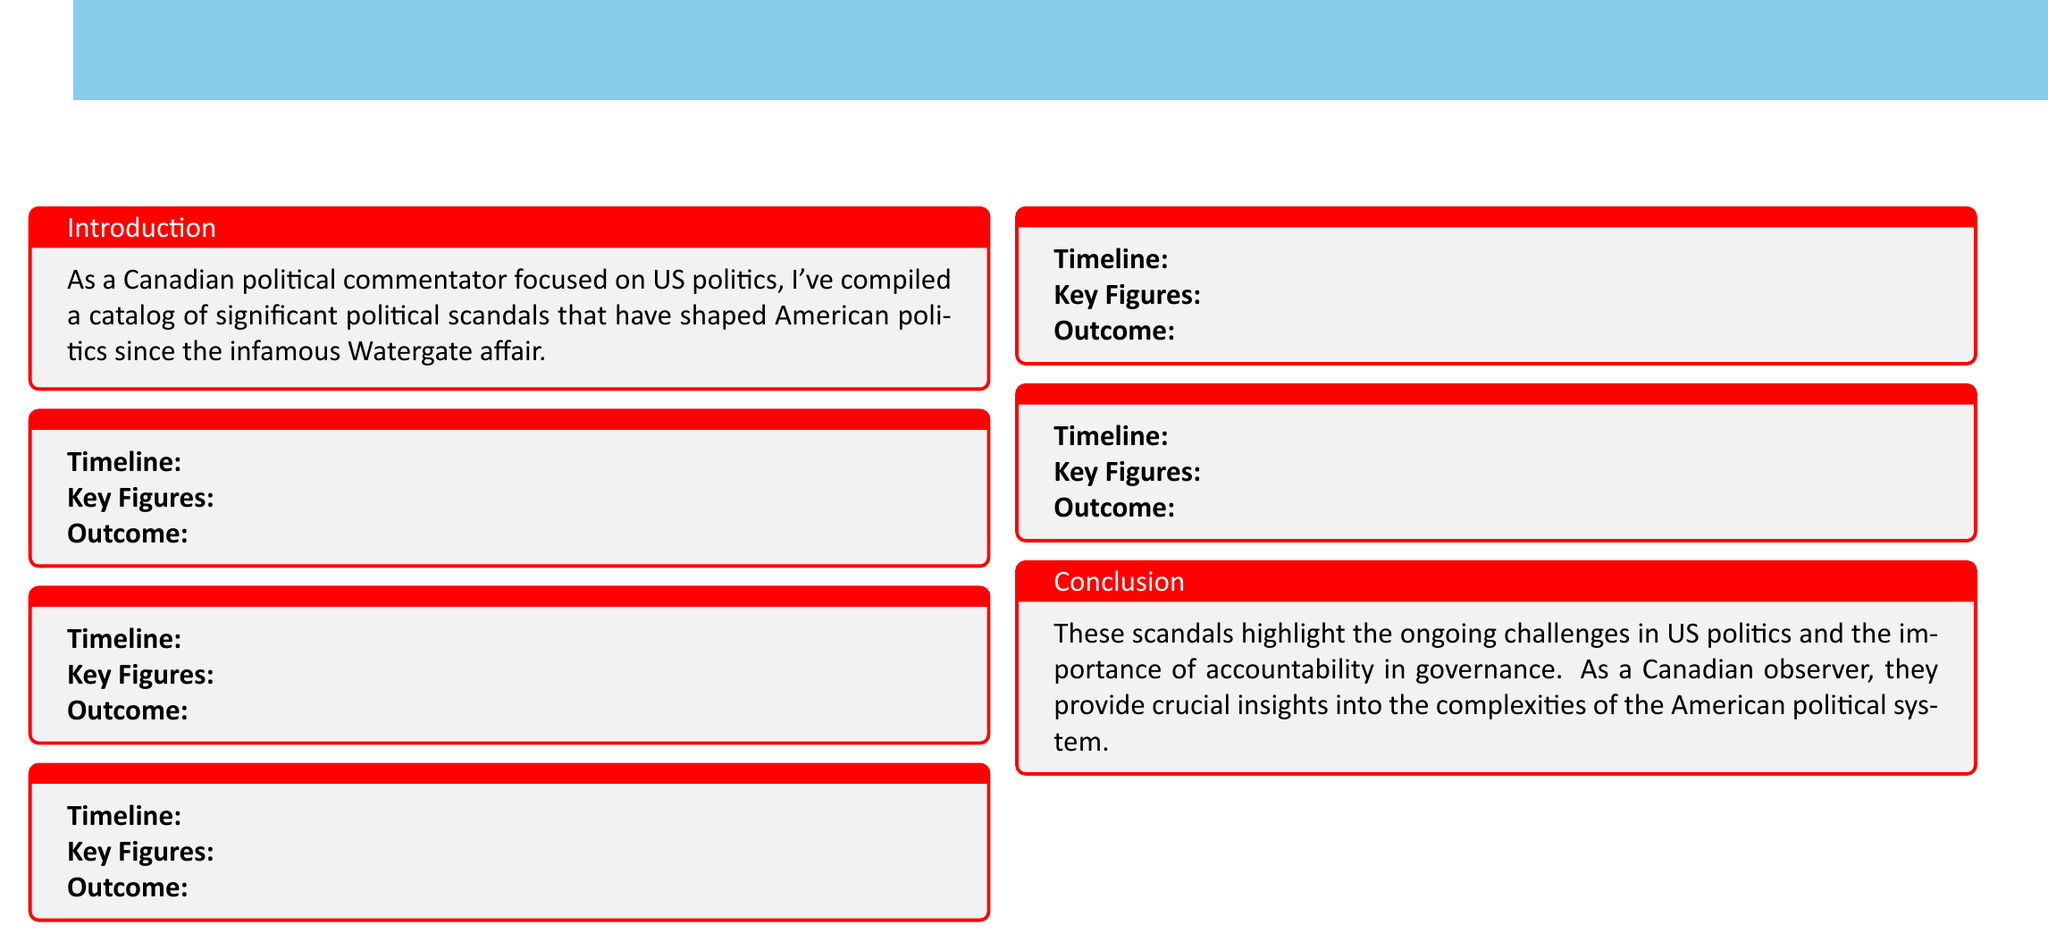What is the first scandal listed in the catalog? The first scandal is the one mentioned at the beginning of the list, which is the Iran-Contra Affair.
Answer: Iran-Contra Affair What was the timeline of the Clinton-Lewinsky Scandal? The timeline for this scandal is clearly indicated in the document, which specifies the years it spanned.
Answer: 1995-1999 Who were the key figures in the Ukraine Scandal? The key figures are listed in the section dedicated to the Ukraine Scandal, highlighting the prominent individuals involved.
Answer: Donald Trump, Volodymyr Zelensky, Nancy Pelosi How many scandals are mentioned in total? The number of scandals can be inferred from the structure of the catalog, which contains a box for each scandal enumerated.
Answer: 5 Which scandal led to multiple convictions later pardoned? The document specifies outcomes for each scandal, mentioning a notable case of multiple convictions being pardoned.
Answer: Iran-Contra Affair What is the outcome of the Trump-Russia Investigation? The outcome is clearly stated in the section on the Trump-Russia Investigation, summarizing the findings and actions taken.
Answer: No direct collusion found, but multiple indictments of associates What year did the Valerie Plame Affair begin? The start year of this scandal is listed in the timeline associated with it, indicating when it began.
Answer: 2003 Who was acquitted by the Senate? The document mentions this information in connection with the outcomes of both the Clinton-Lewinsky and Ukraine scandals.
Answer: Bill Clinton, Donald Trump What color scheme is used in the document? The document uses a color scheme that highlights specific elements, which can be inferred from the description provided.
Answer: Maple and Sky 